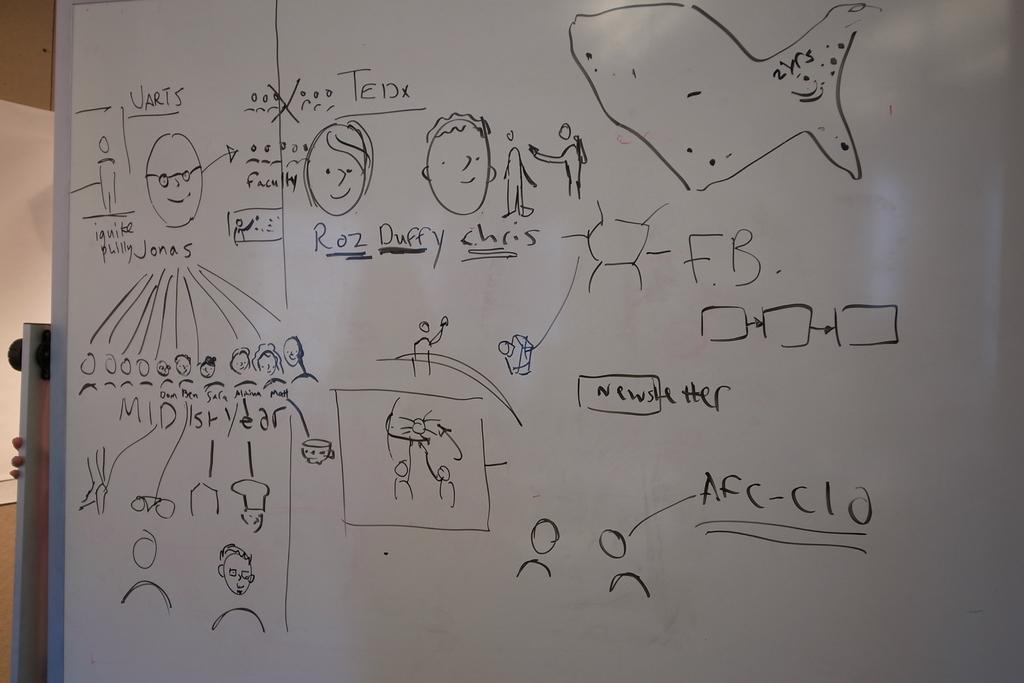<image>
Render a clear and concise summary of the photo. A dry erase whiteboard with Roz Duffy Chris on it 